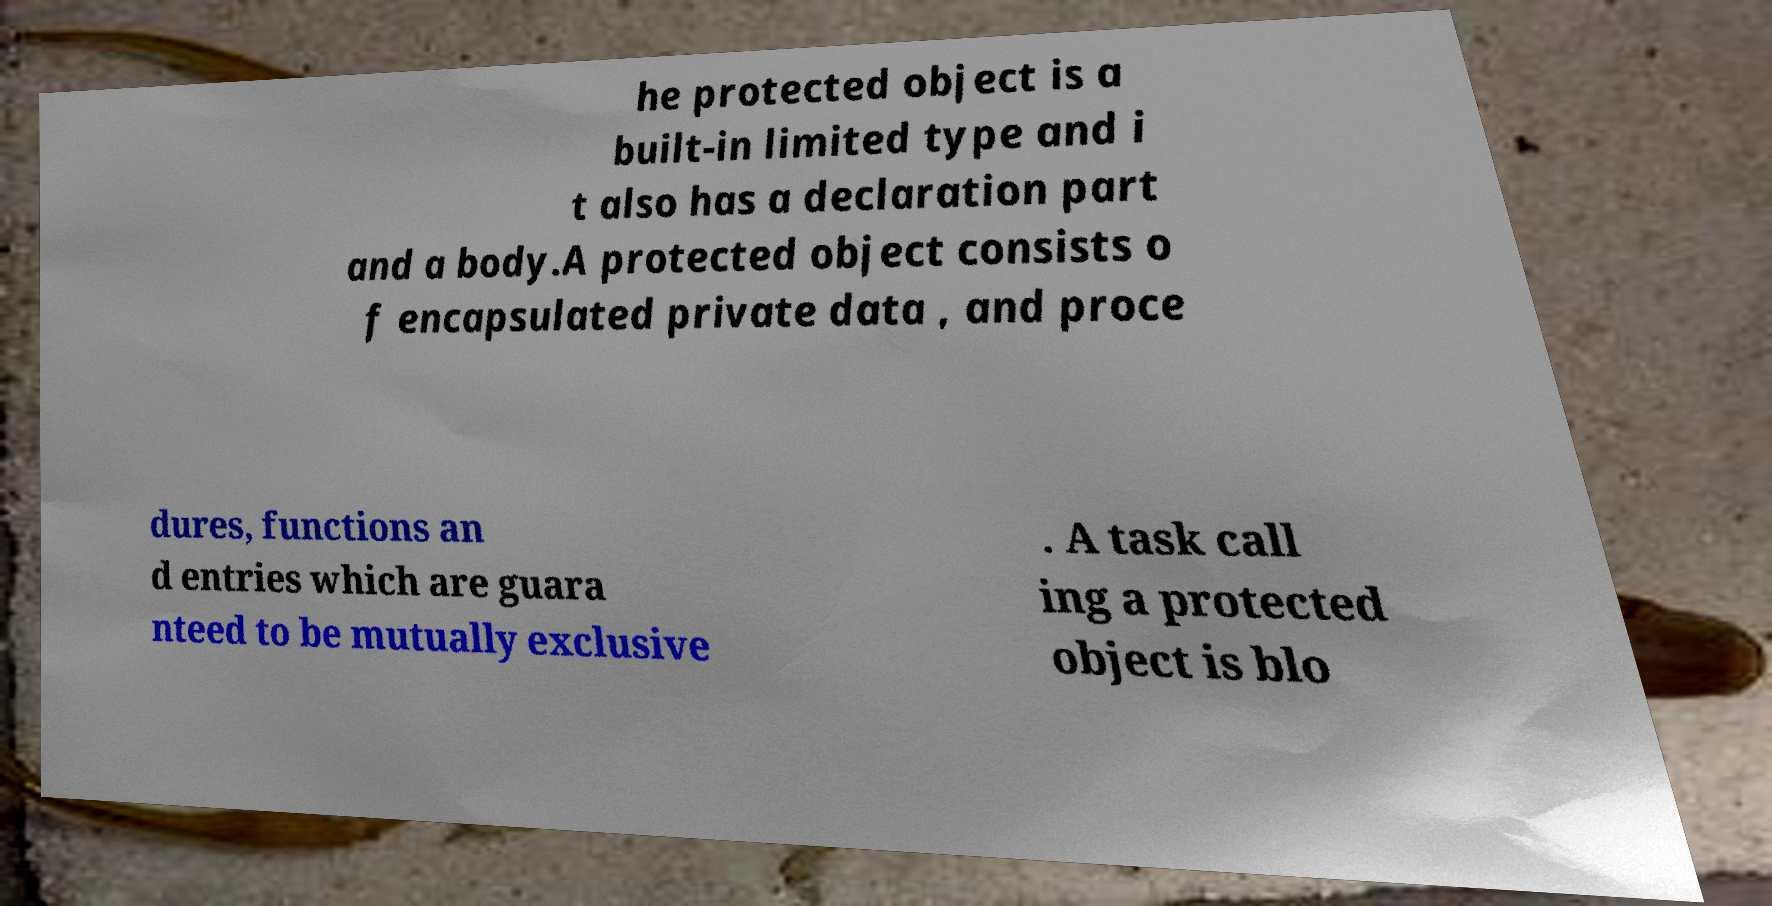Can you accurately transcribe the text from the provided image for me? he protected object is a built-in limited type and i t also has a declaration part and a body.A protected object consists o f encapsulated private data , and proce dures, functions an d entries which are guara nteed to be mutually exclusive . A task call ing a protected object is blo 